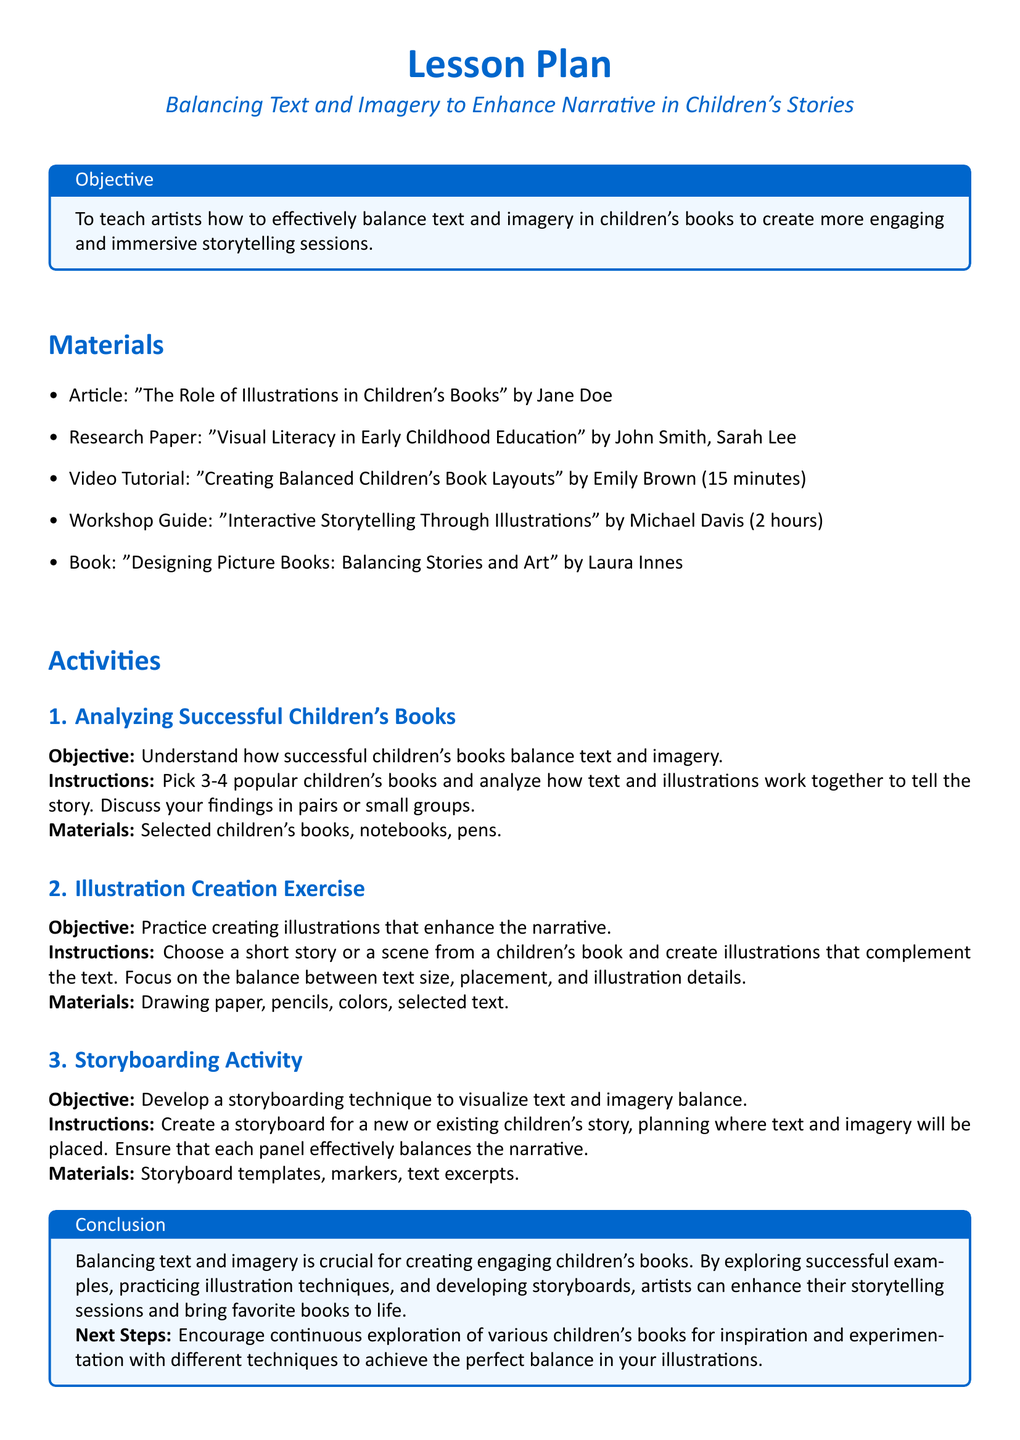What is the title of the lesson plan? The title of the lesson plan is explicitly stated at the beginning of the document.
Answer: Balancing Text and Imagery to Enhance Narrative in Children's Stories Who is the author of the article listed in the materials? The document provides the name of the author associated with the article in the materials section.
Answer: Jane Doe How long is the video tutorial mentioned in the lesson plan? The duration of the video tutorial is specified in the materials section.
Answer: 15 minutes What is the objective of the "Illustration Creation Exercise"? The objective is stated clearly for each activity in the lesson plan.
Answer: Practice creating illustrations that enhance the narrative What materials are needed for the Storyboarding Activity? The materials required for this activity are listed under its instructions.
Answer: Storyboard templates, markers, text excerpts What technique is suggested in the lesson plan to balance text and imagery? The document emphasizes creating storyboards as a technique for balancing narrative elements.
Answer: Storyboarding technique What is the next step suggested at the end of the lesson plan? The lesson plan outlines a next step to encourage continuous exploration for further learning.
Answer: Encourage continuous exploration of various children's books How many popular children's books should be analyzed in the first activity? The lesson plan specifies a quantity of books to analyze for the activity.
Answer: 3-4 What is the title of the book mentioned in the materials? The document lists the title of one of the books included in the materials section.
Answer: Designing Picture Books: Balancing Stories and Art 